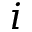<formula> <loc_0><loc_0><loc_500><loc_500>i</formula> 